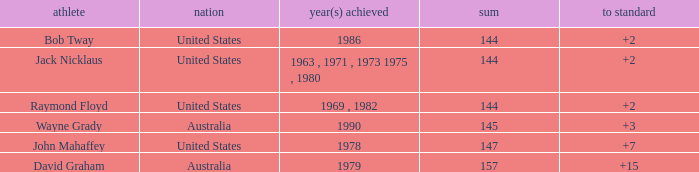How many strokes off par was the winner in 1978? 7.0. 